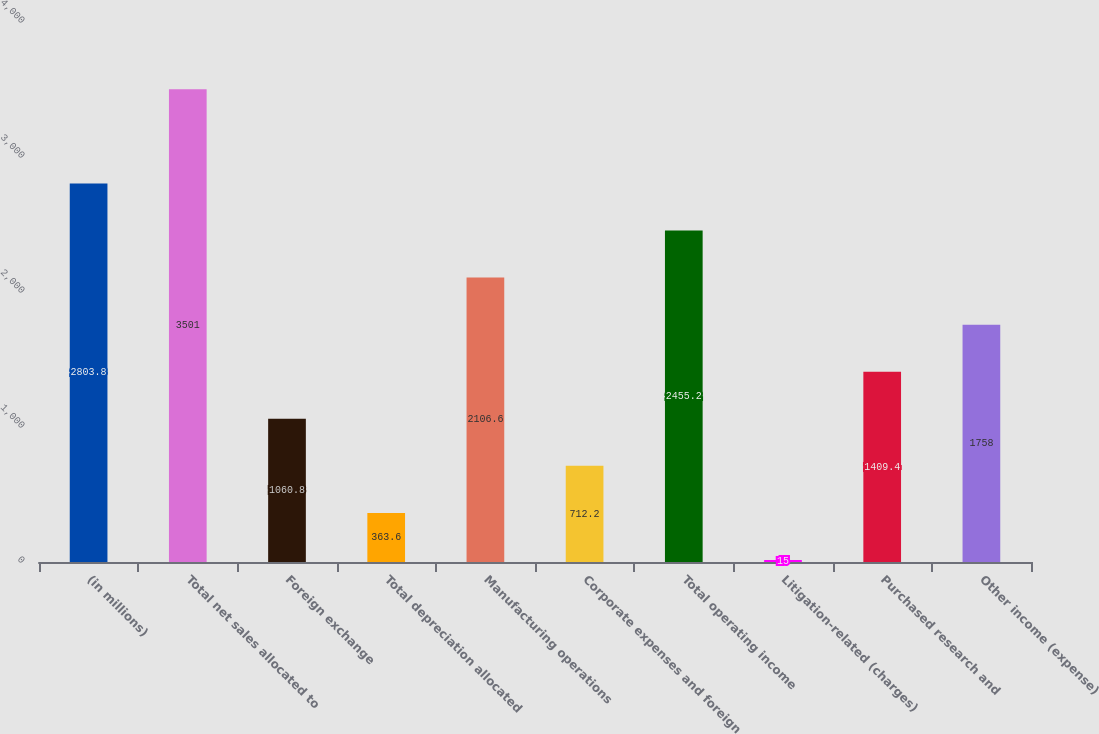Convert chart. <chart><loc_0><loc_0><loc_500><loc_500><bar_chart><fcel>(in millions)<fcel>Total net sales allocated to<fcel>Foreign exchange<fcel>Total depreciation allocated<fcel>Manufacturing operations<fcel>Corporate expenses and foreign<fcel>Total operating income<fcel>Litigation-related (charges)<fcel>Purchased research and<fcel>Other income (expense)<nl><fcel>2803.8<fcel>3501<fcel>1060.8<fcel>363.6<fcel>2106.6<fcel>712.2<fcel>2455.2<fcel>15<fcel>1409.4<fcel>1758<nl></chart> 